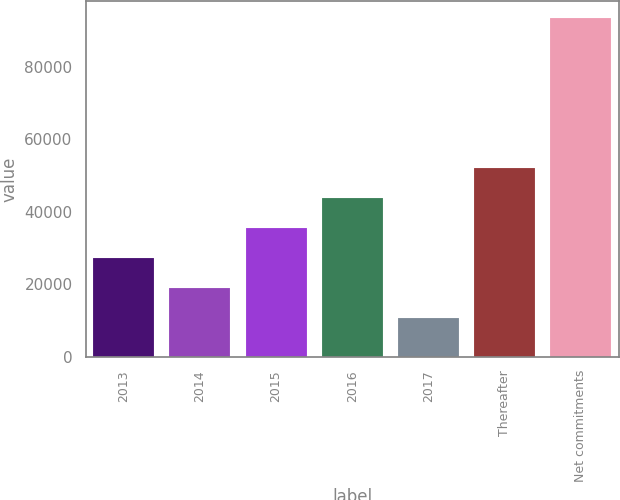Convert chart. <chart><loc_0><loc_0><loc_500><loc_500><bar_chart><fcel>2013<fcel>2014<fcel>2015<fcel>2016<fcel>2017<fcel>Thereafter<fcel>Net commitments<nl><fcel>27358.4<fcel>19085.2<fcel>35631.6<fcel>43904.8<fcel>10812<fcel>52178<fcel>93544<nl></chart> 